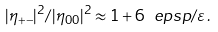Convert formula to latex. <formula><loc_0><loc_0><loc_500><loc_500>| \eta _ { + - } | ^ { 2 } / | \eta _ { 0 0 } | ^ { 2 } \approx 1 + 6 \real { \ e p s p / \varepsilon } \, .</formula> 